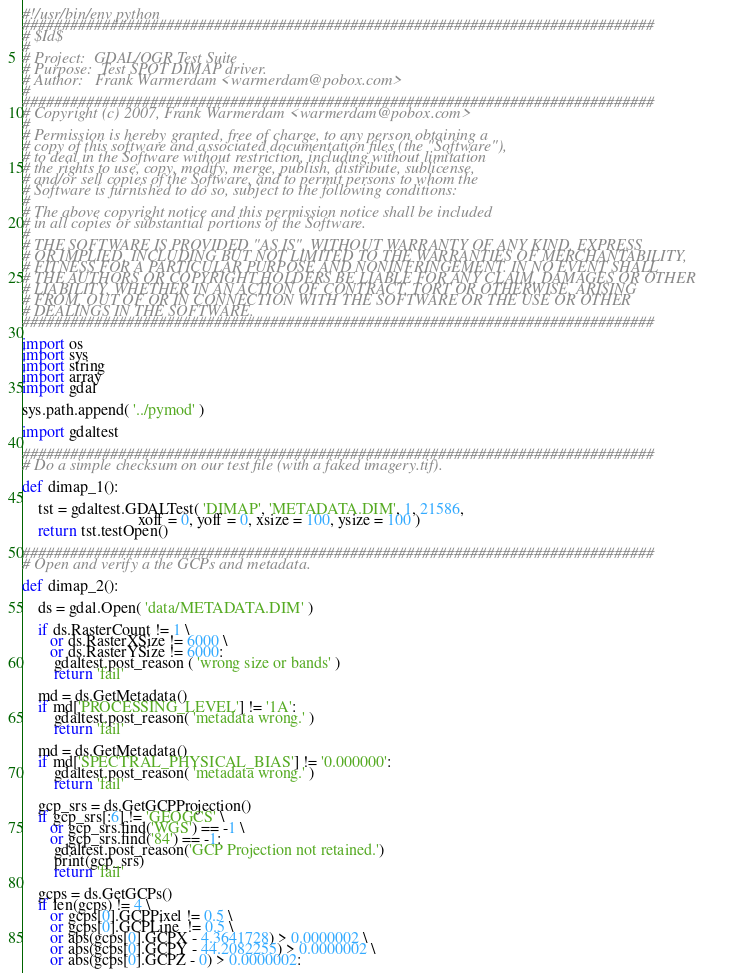<code> <loc_0><loc_0><loc_500><loc_500><_Python_>#!/usr/bin/env python
###############################################################################
# $Id$
#
# Project:  GDAL/OGR Test Suite
# Purpose:  Test SPOT DIMAP driver.
# Author:   Frank Warmerdam <warmerdam@pobox.com>
# 
###############################################################################
# Copyright (c) 2007, Frank Warmerdam <warmerdam@pobox.com>
# 
# Permission is hereby granted, free of charge, to any person obtaining a
# copy of this software and associated documentation files (the "Software"),
# to deal in the Software without restriction, including without limitation
# the rights to use, copy, modify, merge, publish, distribute, sublicense,
# and/or sell copies of the Software, and to permit persons to whom the
# Software is furnished to do so, subject to the following conditions:
#
# The above copyright notice and this permission notice shall be included
# in all copies or substantial portions of the Software.
# 
# THE SOFTWARE IS PROVIDED "AS IS", WITHOUT WARRANTY OF ANY KIND, EXPRESS
# OR IMPLIED, INCLUDING BUT NOT LIMITED TO THE WARRANTIES OF MERCHANTABILITY,
# FITNESS FOR A PARTICULAR PURPOSE AND NONINFRINGEMENT. IN NO EVENT SHALL
# THE AUTHORS OR COPYRIGHT HOLDERS BE LIABLE FOR ANY CLAIM, DAMAGES OR OTHER
# LIABILITY, WHETHER IN AN ACTION OF CONTRACT, TORT OR OTHERWISE, ARISING
# FROM, OUT OF OR IN CONNECTION WITH THE SOFTWARE OR THE USE OR OTHER
# DEALINGS IN THE SOFTWARE.
###############################################################################

import os
import sys
import string
import array
import gdal

sys.path.append( '../pymod' )

import gdaltest

###############################################################################
# Do a simple checksum on our test file (with a faked imagery.tif).

def dimap_1():

    tst = gdaltest.GDALTest( 'DIMAP', 'METADATA.DIM', 1, 21586,
                             xoff = 0, yoff = 0, xsize = 100, ysize = 100 )
    return tst.testOpen()

###############################################################################
# Open and verify a the GCPs and metadata.

def dimap_2():

    ds = gdal.Open( 'data/METADATA.DIM' )

    if ds.RasterCount != 1 \
       or ds.RasterXSize != 6000 \
       or ds.RasterYSize != 6000:
        gdaltest.post_reason ( 'wrong size or bands' )
        return 'fail'

    md = ds.GetMetadata()
    if md['PROCESSING_LEVEL'] != '1A':
        gdaltest.post_reason( 'metadata wrong.' )
        return 'fail'
    
    md = ds.GetMetadata()
    if md['SPECTRAL_PHYSICAL_BIAS'] != '0.000000':
        gdaltest.post_reason( 'metadata wrong.' )
        return 'fail'
    
    gcp_srs = ds.GetGCPProjection()
    if gcp_srs[:6] != 'GEOGCS' \
       or gcp_srs.find('WGS') == -1 \
       or gcp_srs.find('84') == -1:
        gdaltest.post_reason('GCP Projection not retained.')
        print(gcp_srs)
        return 'fail'

    gcps = ds.GetGCPs()
    if len(gcps) != 4 \
       or gcps[0].GCPPixel != 0.5 \
       or gcps[0].GCPLine  != 0.5 \
       or abs(gcps[0].GCPX - 4.3641728) > 0.0000002 \
       or abs(gcps[0].GCPY - 44.2082255) > 0.0000002 \
       or abs(gcps[0].GCPZ - 0) > 0.0000002:</code> 